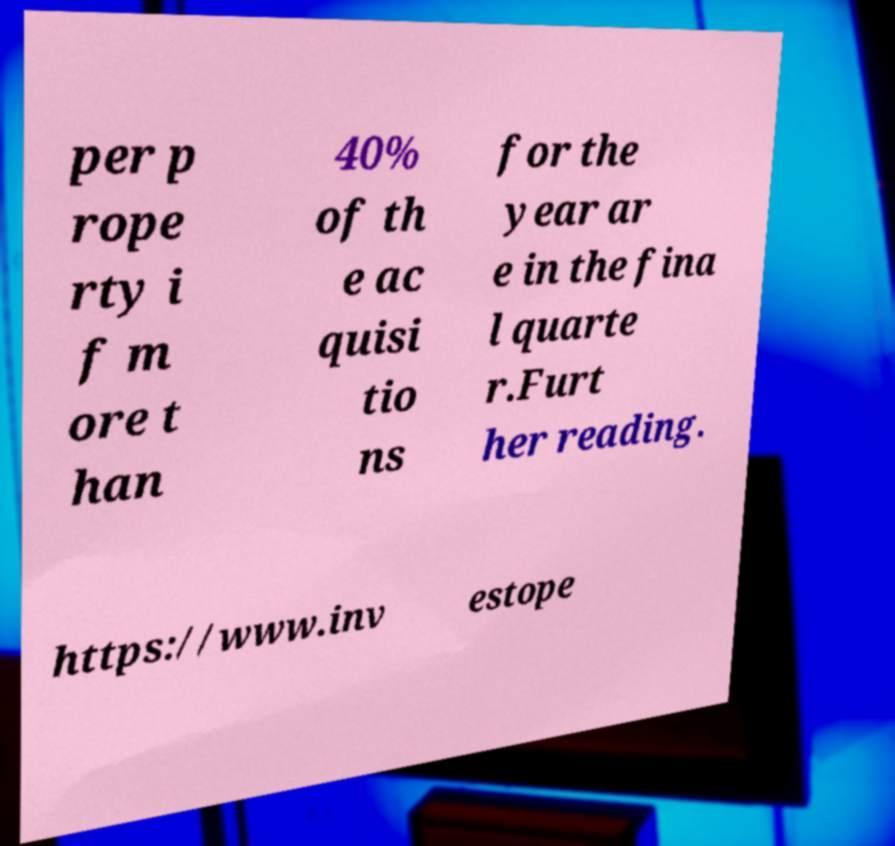Can you read and provide the text displayed in the image?This photo seems to have some interesting text. Can you extract and type it out for me? per p rope rty i f m ore t han 40% of th e ac quisi tio ns for the year ar e in the fina l quarte r.Furt her reading. https://www.inv estope 